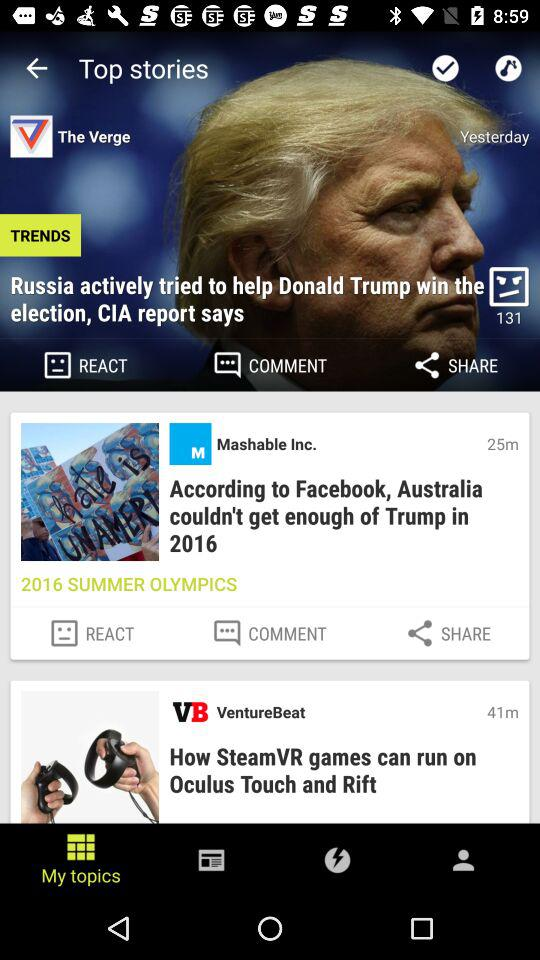What is the headline of the news posted 41 minutes ago? The headline of the news posted 41 minutes ago is "How SteamVR games can run on Oculus Touch and Rift". 